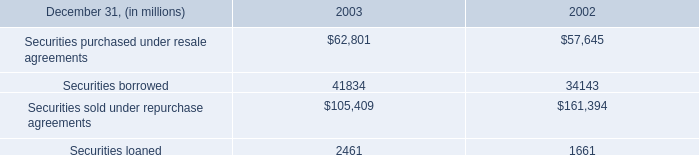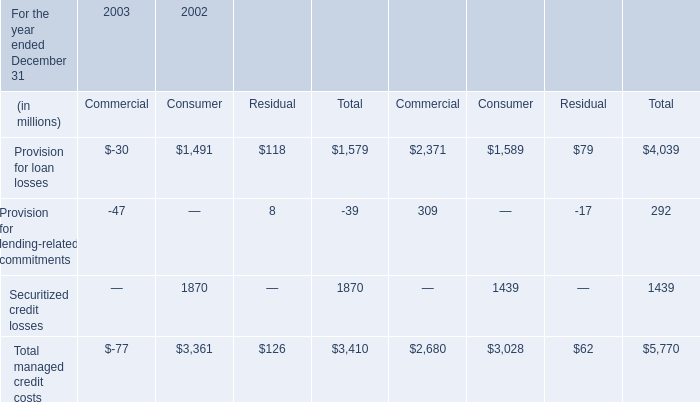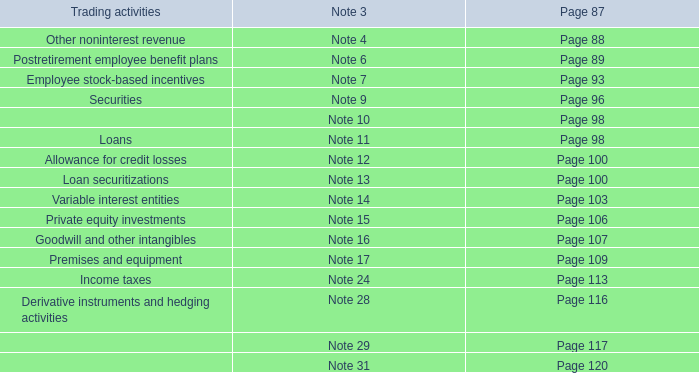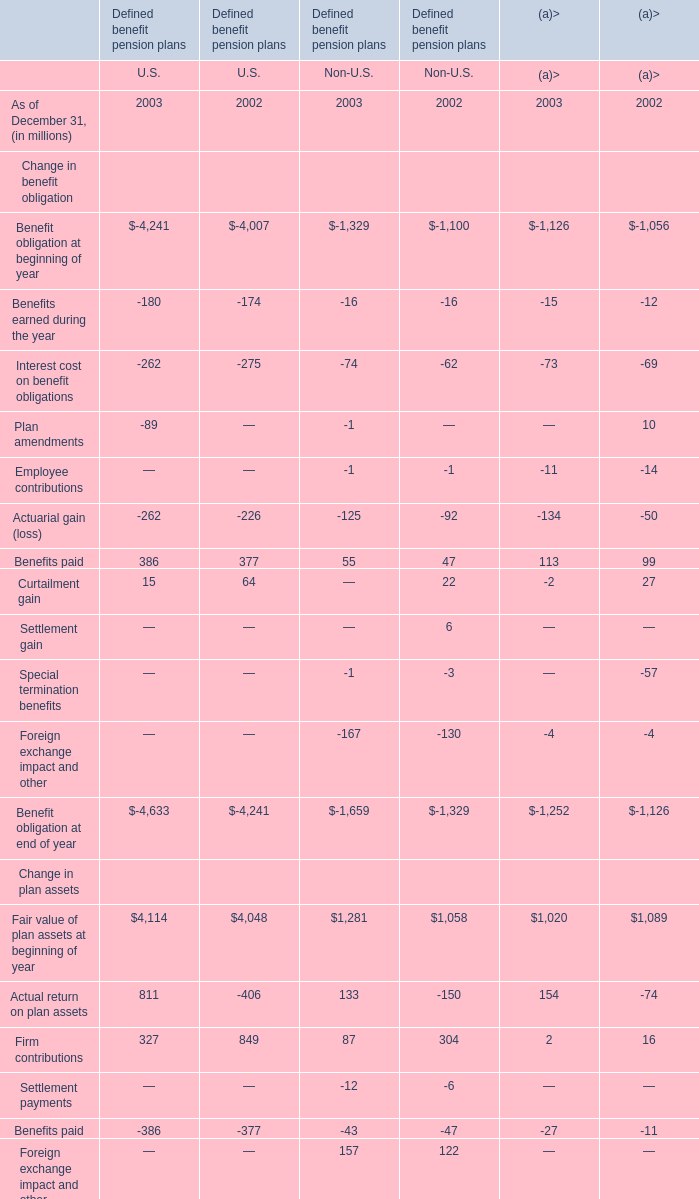What is the total amount of Securitized credit losses of 2002 Consumer, Securities sold under repurchase agreements of 2003, and Securitized credit losses of 2002 Total ? 
Computations: ((1870.0 + 105409.0) + 1870.0)
Answer: 109149.0. 